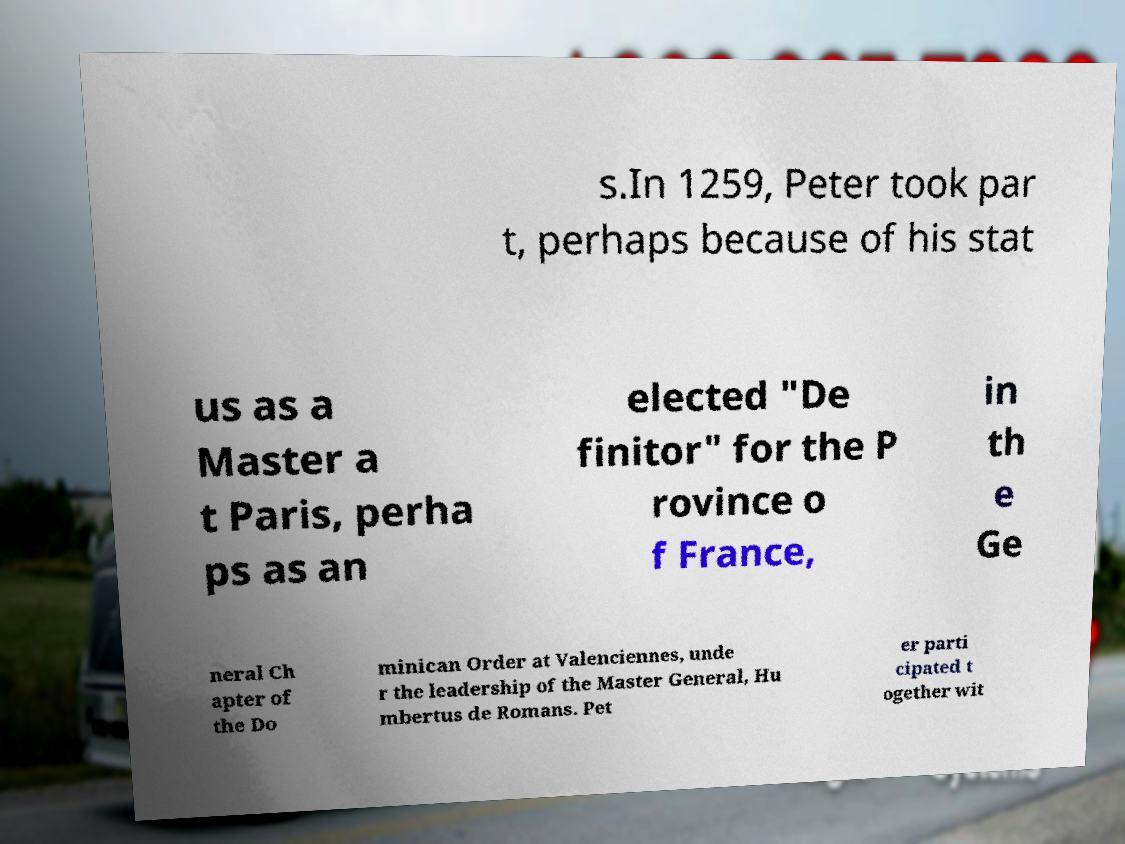Could you assist in decoding the text presented in this image and type it out clearly? s.In 1259, Peter took par t, perhaps because of his stat us as a Master a t Paris, perha ps as an elected "De finitor" for the P rovince o f France, in th e Ge neral Ch apter of the Do minican Order at Valenciennes, unde r the leadership of the Master General, Hu mbertus de Romans. Pet er parti cipated t ogether wit 